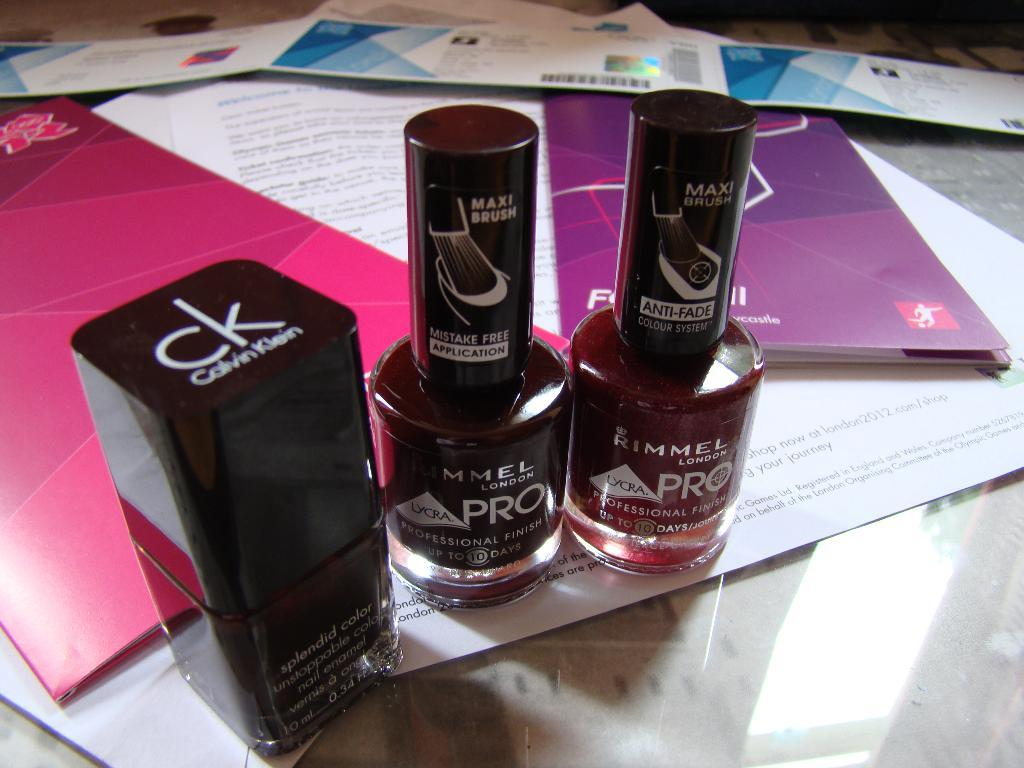<image>
Describe the image concisely. A bottle of Calvin Klein nail polish and two bottles of Rimmel pro polish. 